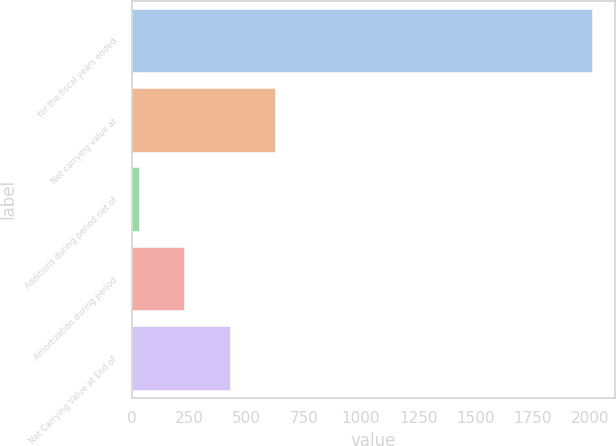Convert chart to OTSL. <chart><loc_0><loc_0><loc_500><loc_500><bar_chart><fcel>for the fiscal years ended<fcel>Net carrying value at<fcel>Additions during period net of<fcel>Amortization during period<fcel>Net Carrying Value at End of<nl><fcel>2009<fcel>623.84<fcel>30.2<fcel>228.08<fcel>425.96<nl></chart> 